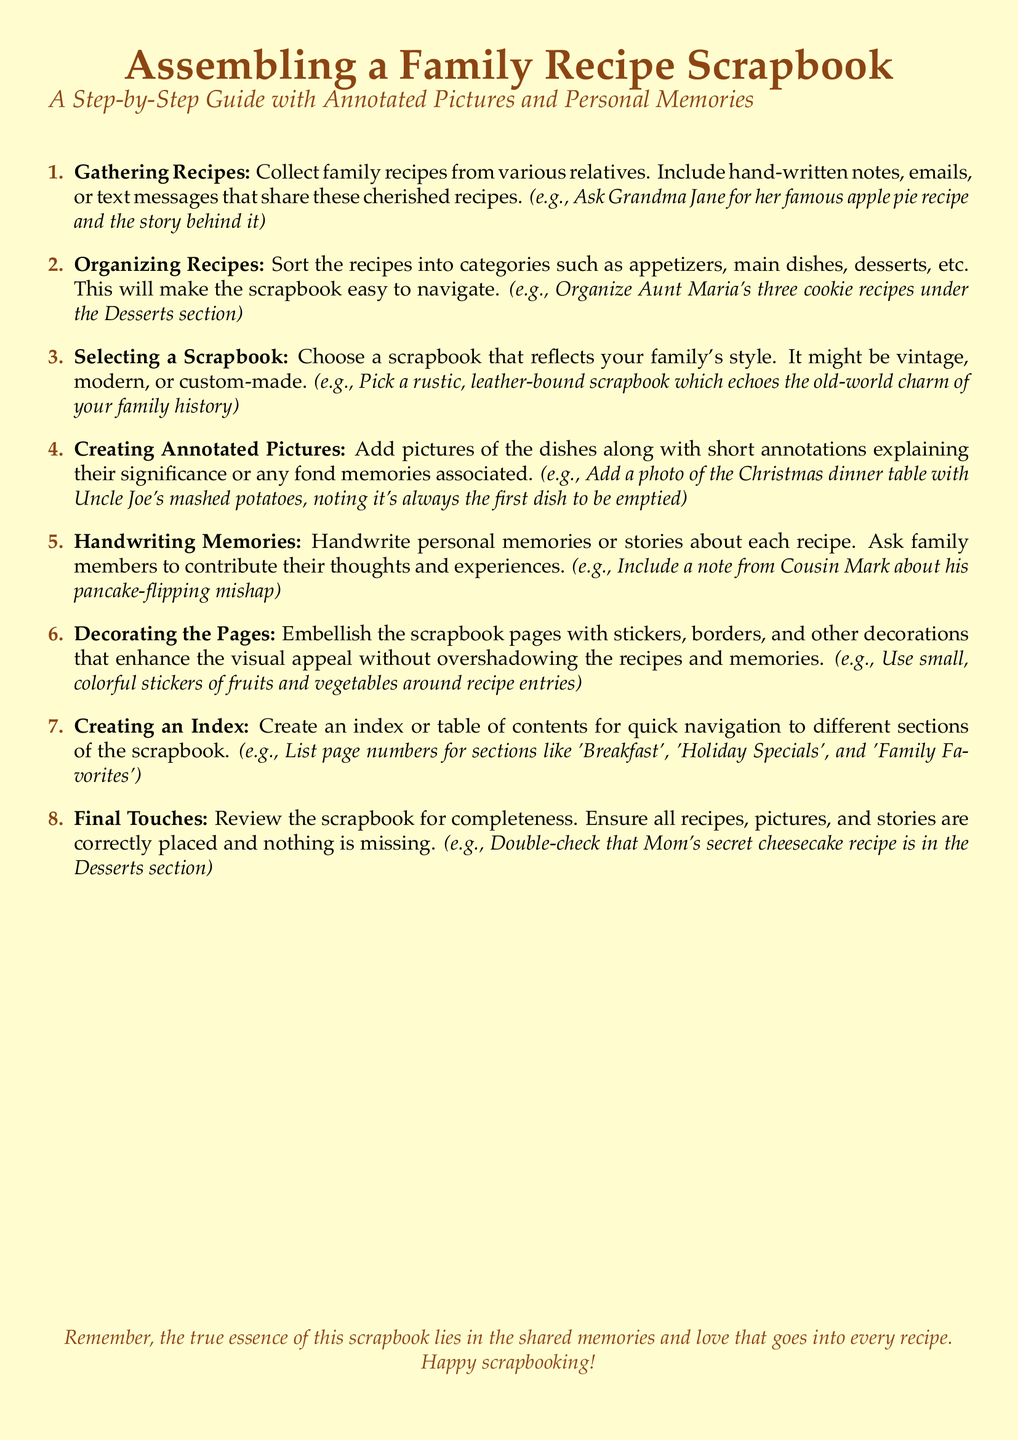What is the first step in assembling the scrapbook? The first step involves collecting family recipes from various relatives, including hand-written notes, emails, or text messages.
Answer: Gathering Recipes How many categories should the recipes be sorted into? The recipes should be sorted into categories such as appetizers, main dishes, desserts, etc.
Answer: Multiple categories What type of scrapbook is recommended? It is suggested to choose a scrapbook that reflects the family's style, potentially vintage, modern, or custom-made.
Answer: Reflecting style What should be included with the pictures of the dishes? Short annotations explaining the significance or any fond memories associated with the dishes should be included.
Answer: Short annotations Which family member is mentioned in relation to a pancake-flipping mishap? Cousin Mark is referenced regarding his pancake-flipping mishap.
Answer: Cousin Mark What decorative elements are suggested for the pages? Stickers, borders, and other decorations that enhance visual appeal without overshadowing the recipes.
Answer: Stickers and borders What is the purpose of creating an index? An index is created for quick navigation to different sections of the scrapbook.
Answer: Quick navigation What should be done as part of the final touches? Review the scrapbook for completeness and ensure all recipes, pictures, and stories are correctly placed and nothing is missing.
Answer: Review for completeness 